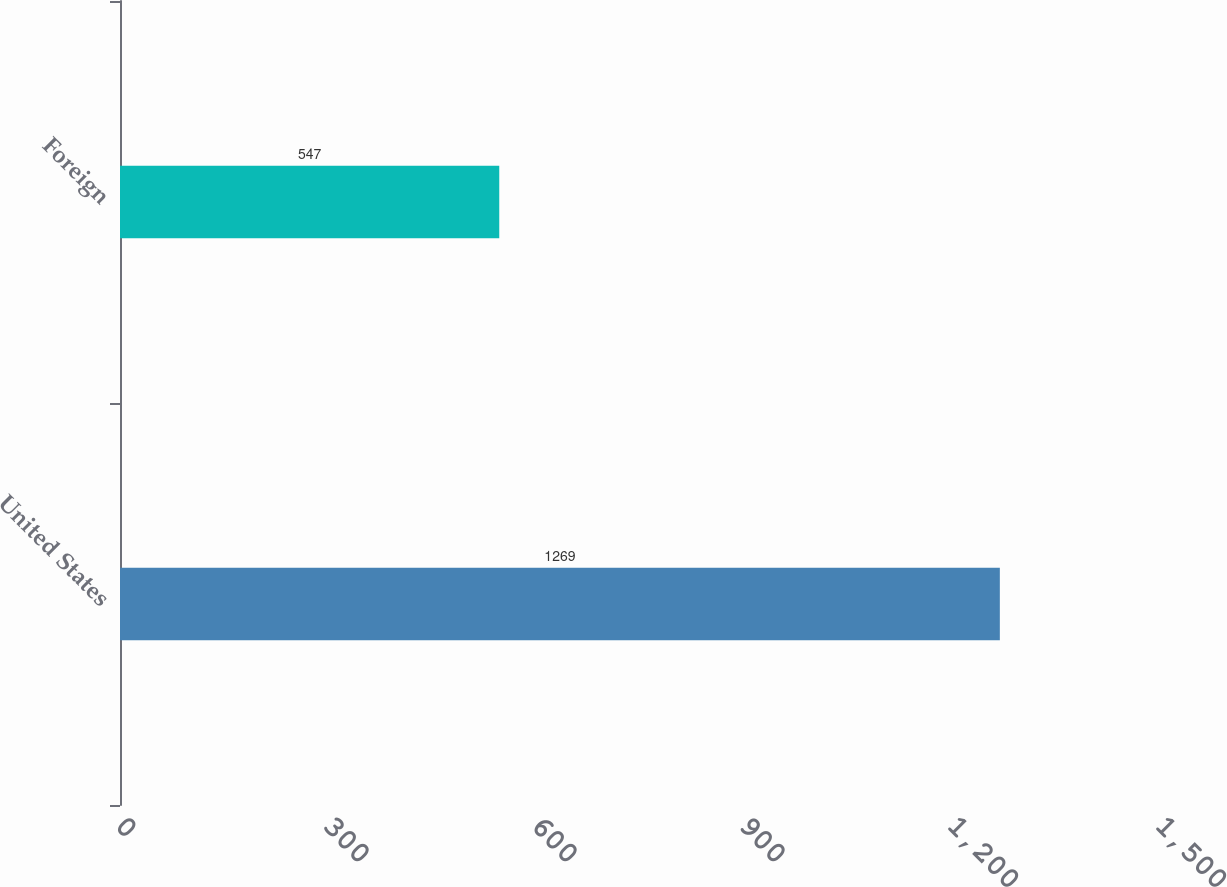Convert chart. <chart><loc_0><loc_0><loc_500><loc_500><bar_chart><fcel>United States<fcel>Foreign<nl><fcel>1269<fcel>547<nl></chart> 